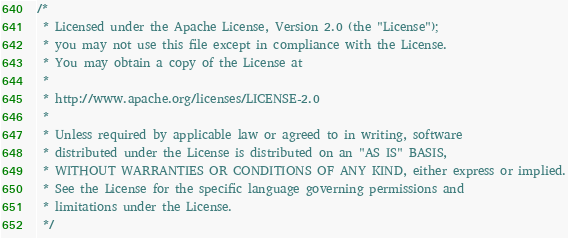Convert code to text. <code><loc_0><loc_0><loc_500><loc_500><_Java_>/*
 * Licensed under the Apache License, Version 2.0 (the "License");
 * you may not use this file except in compliance with the License.
 * You may obtain a copy of the License at
 *
 * http://www.apache.org/licenses/LICENSE-2.0
 *
 * Unless required by applicable law or agreed to in writing, software
 * distributed under the License is distributed on an "AS IS" BASIS,
 * WITHOUT WARRANTIES OR CONDITIONS OF ANY KIND, either express or implied.
 * See the License for the specific language governing permissions and
 * limitations under the License.
 */
</code> 